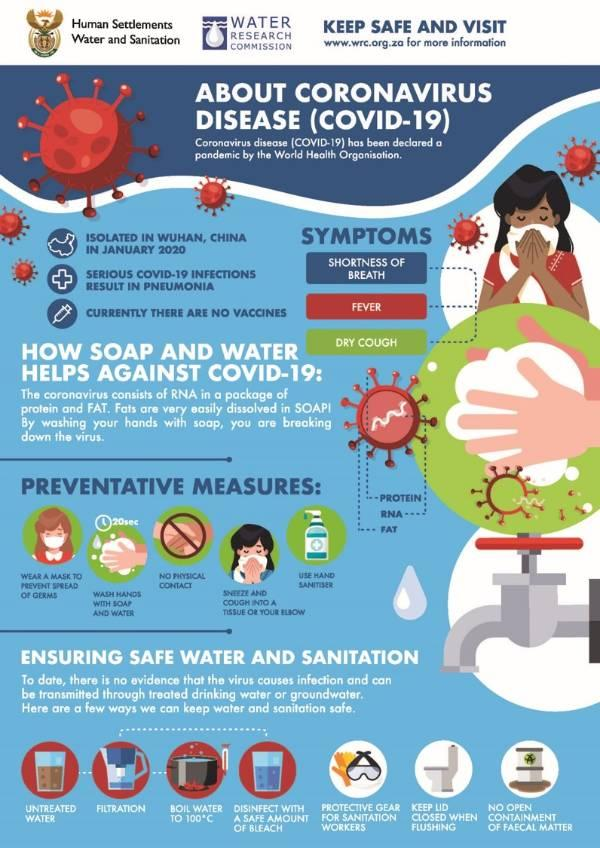Specify some key components in this picture. Coronavirus RNA consists of two components: protein and fat. There are multiple ways to ensure safe water and sanitation, and one of them is by following the 7 steps. There are 5 preventive measures highlighted in this infographic. 